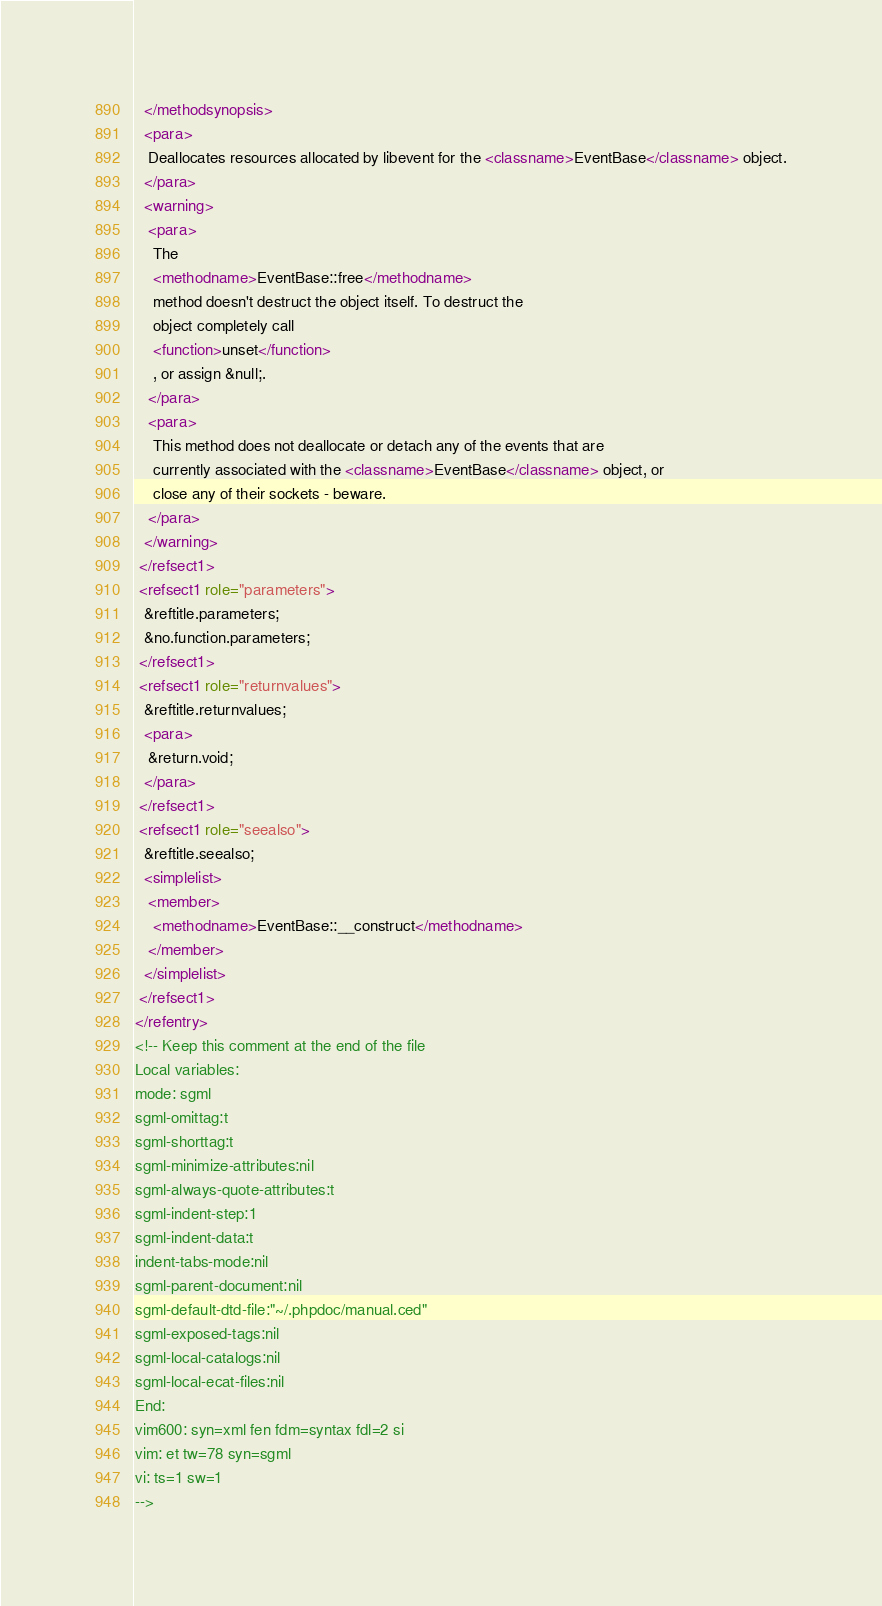<code> <loc_0><loc_0><loc_500><loc_500><_XML_>  </methodsynopsis>
  <para>
   Deallocates resources allocated by libevent for the <classname>EventBase</classname> object.
  </para>
  <warning>
   <para>
    The
    <methodname>EventBase::free</methodname>
    method doesn't destruct the object itself. To destruct the
    object completely call
    <function>unset</function>
    , or assign &null;.
   </para>
   <para>
    This method does not deallocate or detach any of the events that are
    currently associated with the <classname>EventBase</classname> object, or
    close any of their sockets - beware.
   </para>
  </warning>
 </refsect1>
 <refsect1 role="parameters">
  &reftitle.parameters;
  &no.function.parameters;
 </refsect1>
 <refsect1 role="returnvalues">
  &reftitle.returnvalues;
  <para>
   &return.void;
  </para>
 </refsect1>
 <refsect1 role="seealso">
  &reftitle.seealso;
  <simplelist>
   <member>
    <methodname>EventBase::__construct</methodname>
   </member>
  </simplelist>
 </refsect1>
</refentry>
<!-- Keep this comment at the end of the file
Local variables:
mode: sgml
sgml-omittag:t
sgml-shorttag:t
sgml-minimize-attributes:nil
sgml-always-quote-attributes:t
sgml-indent-step:1
sgml-indent-data:t
indent-tabs-mode:nil
sgml-parent-document:nil
sgml-default-dtd-file:"~/.phpdoc/manual.ced"
sgml-exposed-tags:nil
sgml-local-catalogs:nil
sgml-local-ecat-files:nil
End:
vim600: syn=xml fen fdm=syntax fdl=2 si
vim: et tw=78 syn=sgml
vi: ts=1 sw=1
-->
</code> 